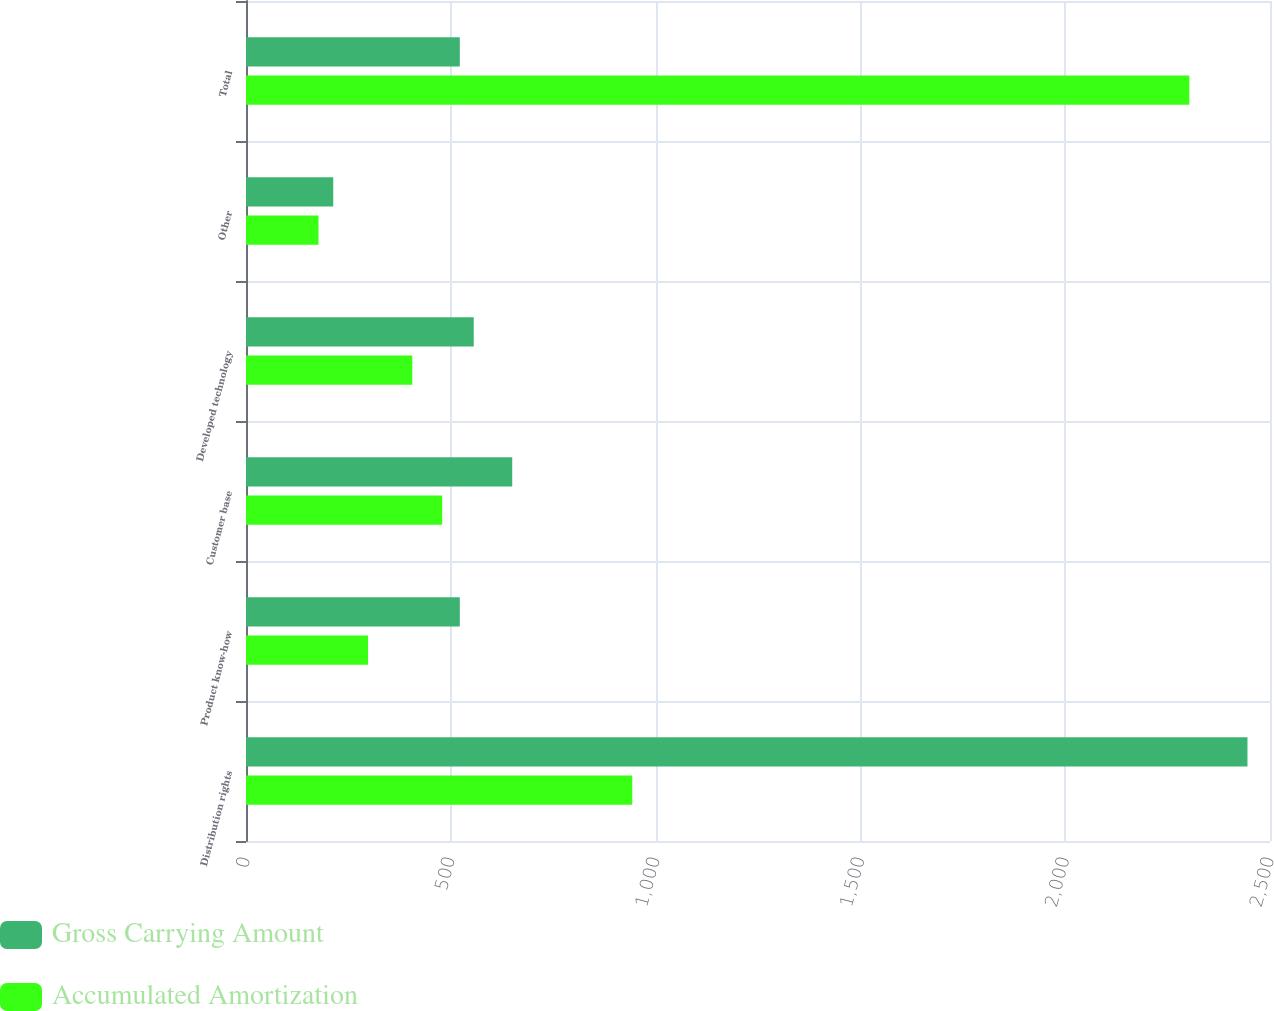Convert chart to OTSL. <chart><loc_0><loc_0><loc_500><loc_500><stacked_bar_chart><ecel><fcel>Distribution rights<fcel>Product know-how<fcel>Customer base<fcel>Developed technology<fcel>Other<fcel>Total<nl><fcel>Gross Carrying Amount<fcel>2445<fcel>522<fcel>650<fcel>556<fcel>213<fcel>522<nl><fcel>Accumulated Amortization<fcel>943<fcel>298<fcel>479<fcel>406<fcel>177<fcel>2303<nl></chart> 